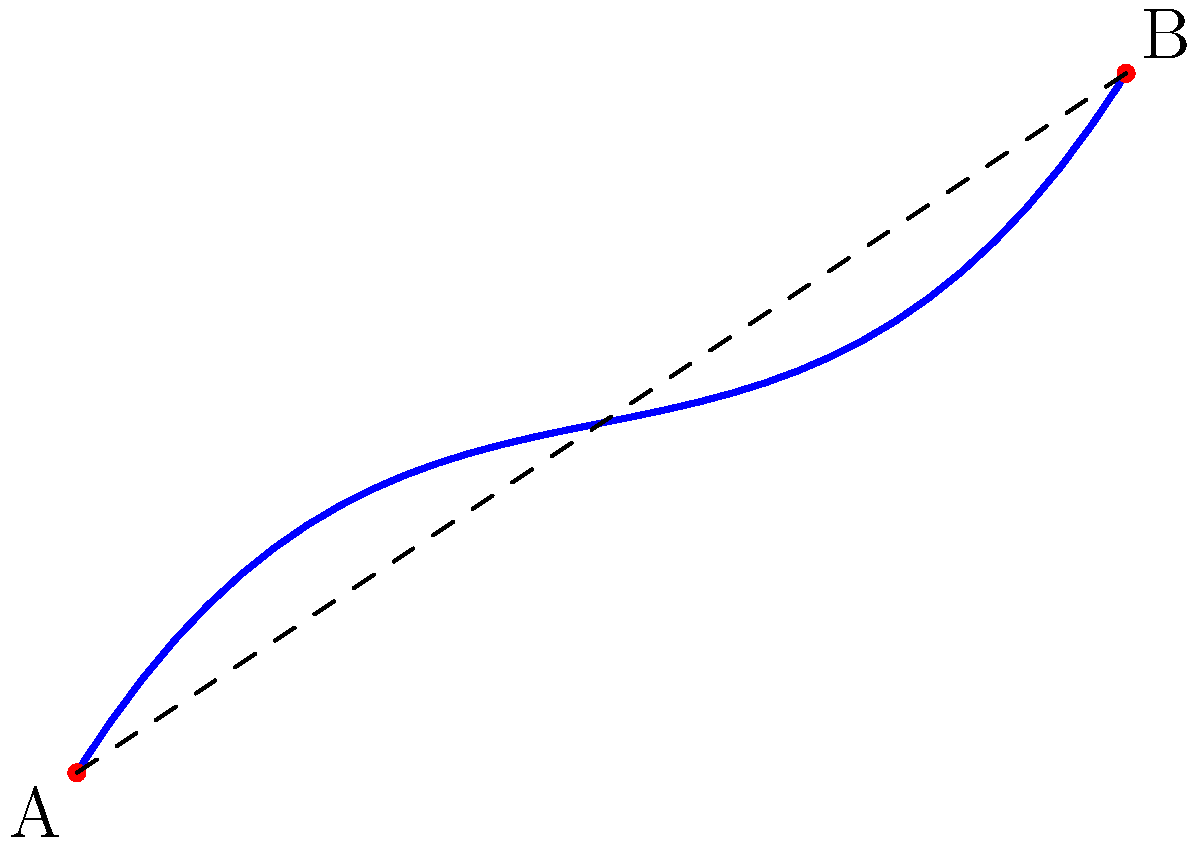In a non-Euclidean neighborhood model of East Hillside, the curved street connecting points A and B represents Superior Street. If the straight-line distance between A and B is 150 meters, but the actual length of the curved street is 180 meters, what is the curvature ratio of this street? To find the curvature ratio of the street, we need to follow these steps:

1. Identify the straight-line distance between points A and B:
   Straight-line distance = 150 meters

2. Identify the actual length of the curved street:
   Curved street length = 180 meters

3. Calculate the curvature ratio:
   Curvature ratio = $\frac{\text{Curved street length}}{\text{Straight-line distance}}$

4. Plug in the values:
   Curvature ratio = $\frac{180 \text{ meters}}{150 \text{ meters}}$

5. Simplify the fraction:
   Curvature ratio = $\frac{6}{5} = 1.2$

The curvature ratio of 1.2 indicates that the curved street is 20% longer than the straight-line distance between points A and B in this non-Euclidean neighborhood model.
Answer: 1.2 